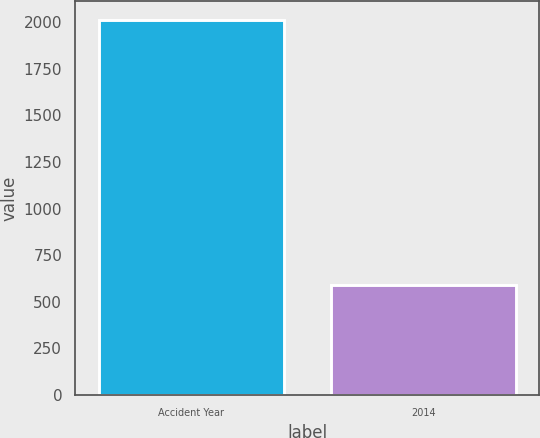Convert chart to OTSL. <chart><loc_0><loc_0><loc_500><loc_500><bar_chart><fcel>Accident Year<fcel>2014<nl><fcel>2014<fcel>591<nl></chart> 